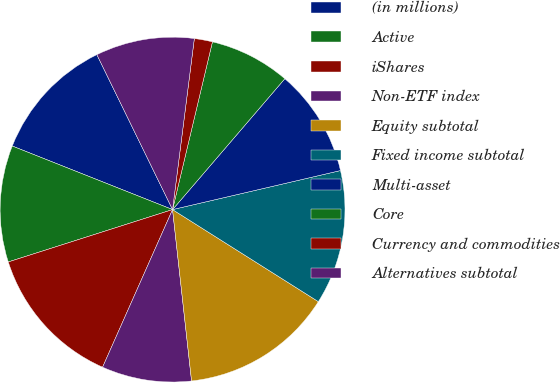<chart> <loc_0><loc_0><loc_500><loc_500><pie_chart><fcel>(in millions)<fcel>Active<fcel>iShares<fcel>Non-ETF index<fcel>Equity subtotal<fcel>Fixed income subtotal<fcel>Multi-asset<fcel>Core<fcel>Currency and commodities<fcel>Alternatives subtotal<nl><fcel>11.76%<fcel>10.92%<fcel>13.44%<fcel>8.41%<fcel>14.28%<fcel>12.6%<fcel>10.08%<fcel>7.57%<fcel>1.7%<fcel>9.25%<nl></chart> 